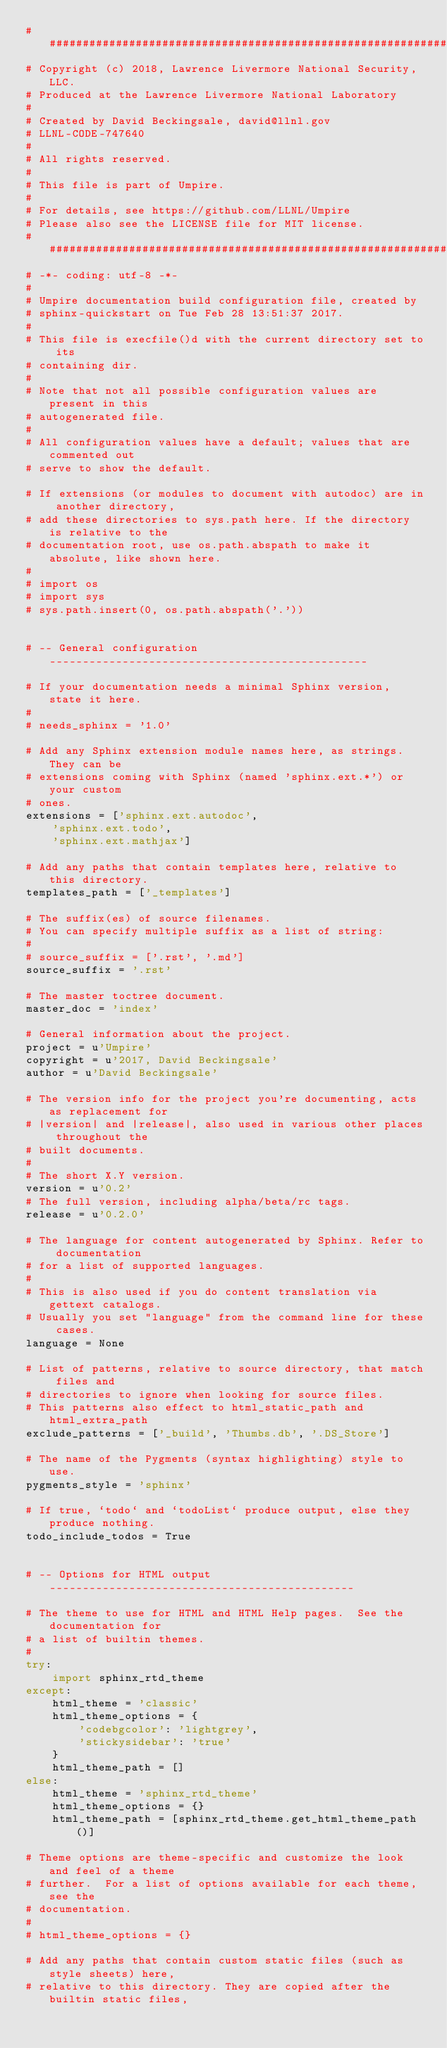<code> <loc_0><loc_0><loc_500><loc_500><_Python_>##############################################################################
# Copyright (c) 2018, Lawrence Livermore National Security, LLC.
# Produced at the Lawrence Livermore National Laboratory
#
# Created by David Beckingsale, david@llnl.gov
# LLNL-CODE-747640
#
# All rights reserved.
#
# This file is part of Umpire.
#
# For details, see https://github.com/LLNL/Umpire
# Please also see the LICENSE file for MIT license.
##############################################################################
# -*- coding: utf-8 -*-
#
# Umpire documentation build configuration file, created by
# sphinx-quickstart on Tue Feb 28 13:51:37 2017.
#
# This file is execfile()d with the current directory set to its
# containing dir.
#
# Note that not all possible configuration values are present in this
# autogenerated file.
#
# All configuration values have a default; values that are commented out
# serve to show the default.

# If extensions (or modules to document with autodoc) are in another directory,
# add these directories to sys.path here. If the directory is relative to the
# documentation root, use os.path.abspath to make it absolute, like shown here.
#
# import os
# import sys
# sys.path.insert(0, os.path.abspath('.'))


# -- General configuration ------------------------------------------------

# If your documentation needs a minimal Sphinx version, state it here.
#
# needs_sphinx = '1.0'

# Add any Sphinx extension module names here, as strings. They can be
# extensions coming with Sphinx (named 'sphinx.ext.*') or your custom
# ones.
extensions = ['sphinx.ext.autodoc',
    'sphinx.ext.todo',
    'sphinx.ext.mathjax']

# Add any paths that contain templates here, relative to this directory.
templates_path = ['_templates']

# The suffix(es) of source filenames.
# You can specify multiple suffix as a list of string:
#
# source_suffix = ['.rst', '.md']
source_suffix = '.rst'

# The master toctree document.
master_doc = 'index'

# General information about the project.
project = u'Umpire'
copyright = u'2017, David Beckingsale'
author = u'David Beckingsale'

# The version info for the project you're documenting, acts as replacement for
# |version| and |release|, also used in various other places throughout the
# built documents.
#
# The short X.Y version.
version = u'0.2'
# The full version, including alpha/beta/rc tags.
release = u'0.2.0'

# The language for content autogenerated by Sphinx. Refer to documentation
# for a list of supported languages.
#
# This is also used if you do content translation via gettext catalogs.
# Usually you set "language" from the command line for these cases.
language = None

# List of patterns, relative to source directory, that match files and
# directories to ignore when looking for source files.
# This patterns also effect to html_static_path and html_extra_path
exclude_patterns = ['_build', 'Thumbs.db', '.DS_Store']

# The name of the Pygments (syntax highlighting) style to use.
pygments_style = 'sphinx'

# If true, `todo` and `todoList` produce output, else they produce nothing.
todo_include_todos = True


# -- Options for HTML output ----------------------------------------------

# The theme to use for HTML and HTML Help pages.  See the documentation for
# a list of builtin themes.
#
try:
    import sphinx_rtd_theme
except:
    html_theme = 'classic'
    html_theme_options = {
        'codebgcolor': 'lightgrey',
        'stickysidebar': 'true'
    }
    html_theme_path = []
else:
    html_theme = 'sphinx_rtd_theme'
    html_theme_options = {}
    html_theme_path = [sphinx_rtd_theme.get_html_theme_path()]

# Theme options are theme-specific and customize the look and feel of a theme
# further.  For a list of options available for each theme, see the
# documentation.
#
# html_theme_options = {}

# Add any paths that contain custom static files (such as style sheets) here,
# relative to this directory. They are copied after the builtin static files,</code> 